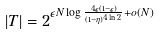Convert formula to latex. <formula><loc_0><loc_0><loc_500><loc_500>| T | = 2 ^ { \epsilon N \log \frac { 4 \epsilon ( 1 - \epsilon ) } { ( 1 - \eta ) ^ { 4 \ln 2 } } + o ( N ) }</formula> 